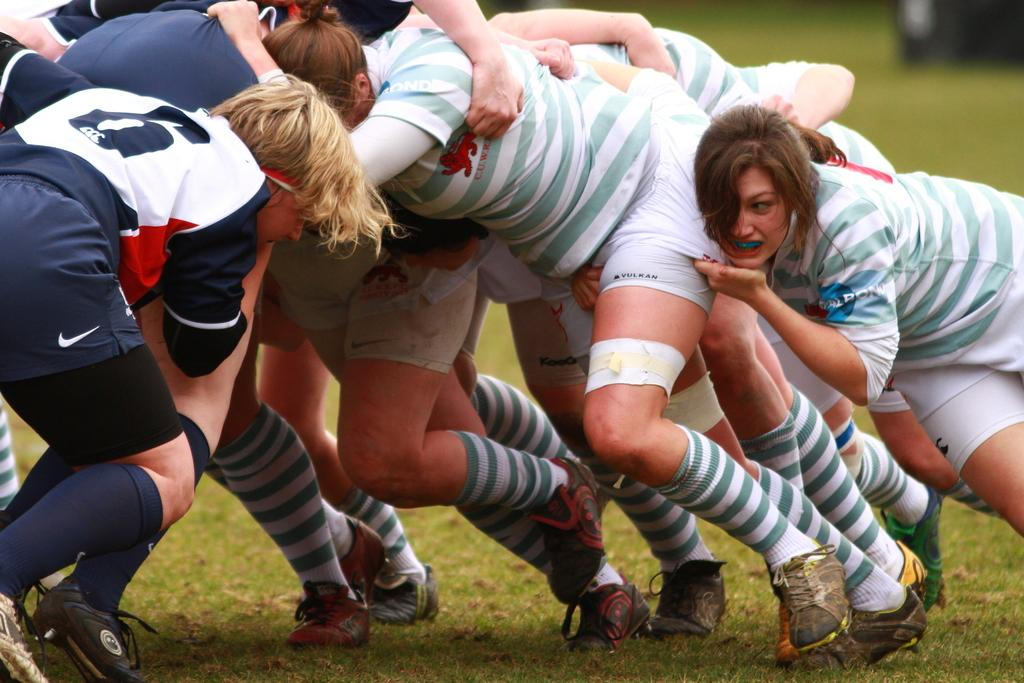Who or what is present in the image? There are people in the image. What are the people wearing? The people are wearing t-shirts and shorts. What activity are the people engaged in? The people appear to be playing a game. What type of surface is visible in the image? There is grass on the ground in the image. What type of tank can be seen in the background of the image? There is no tank present in the image. What type of exchange is taking place between the people in the image? The image does not depict any exchange between the people; they are playing a game. 